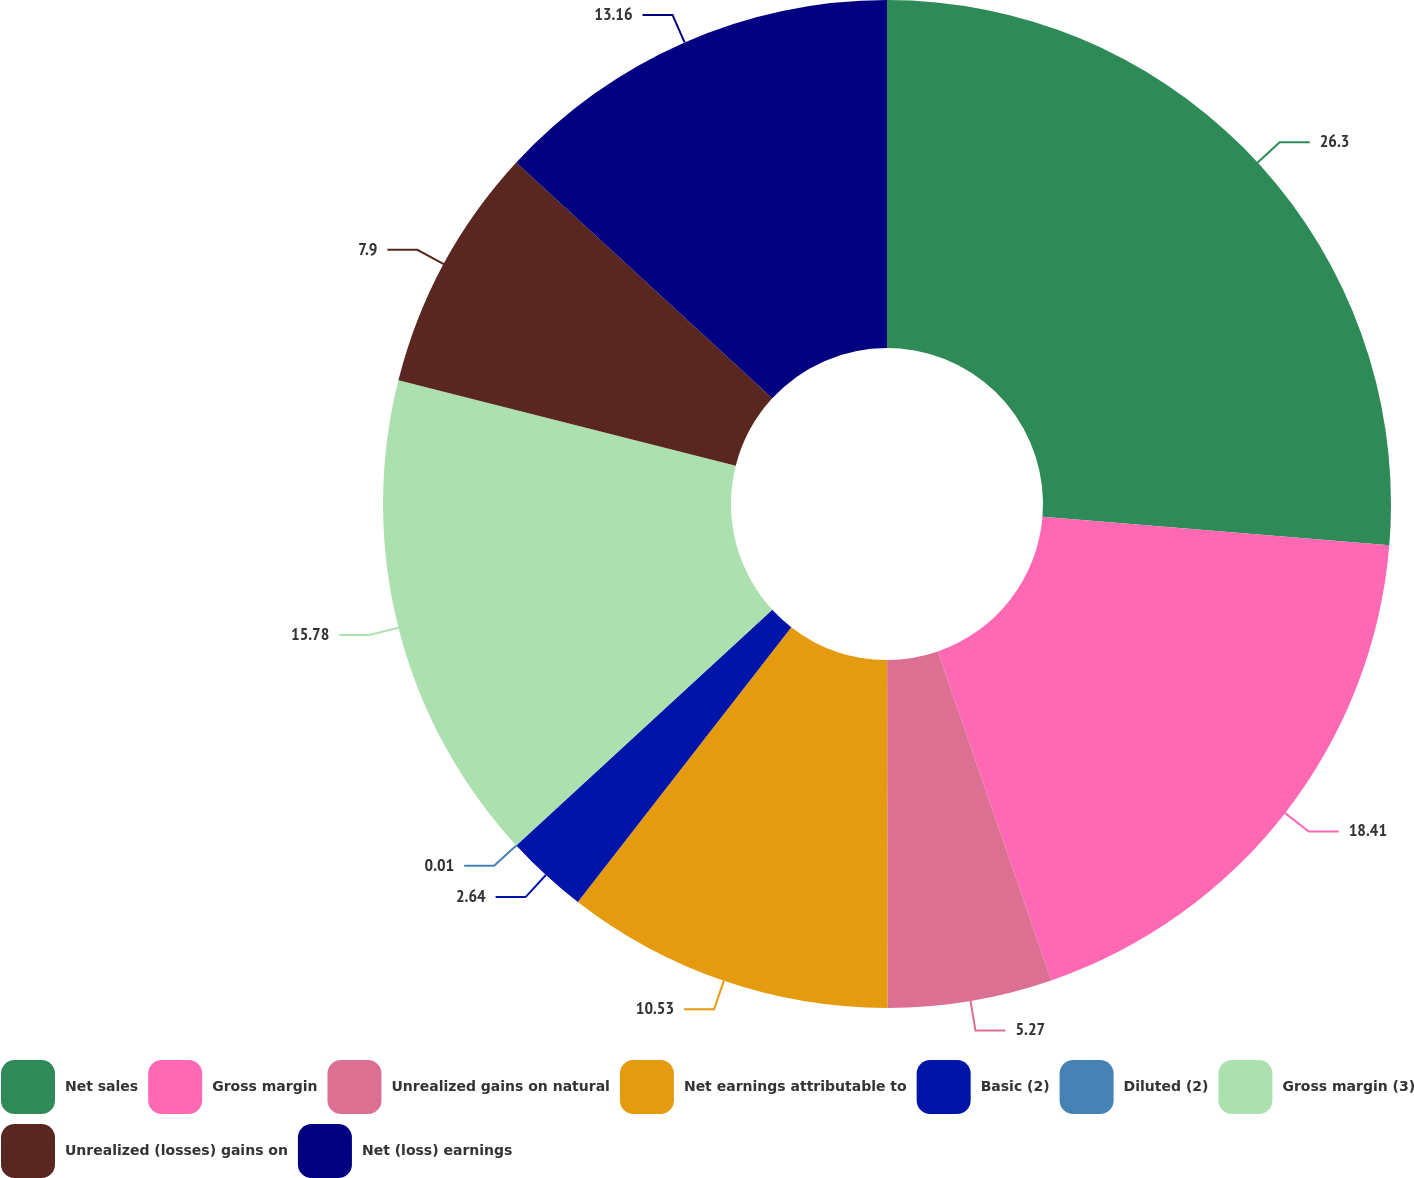Convert chart to OTSL. <chart><loc_0><loc_0><loc_500><loc_500><pie_chart><fcel>Net sales<fcel>Gross margin<fcel>Unrealized gains on natural<fcel>Net earnings attributable to<fcel>Basic (2)<fcel>Diluted (2)<fcel>Gross margin (3)<fcel>Unrealized (losses) gains on<fcel>Net (loss) earnings<nl><fcel>26.31%<fcel>18.42%<fcel>5.27%<fcel>10.53%<fcel>2.64%<fcel>0.01%<fcel>15.79%<fcel>7.9%<fcel>13.16%<nl></chart> 